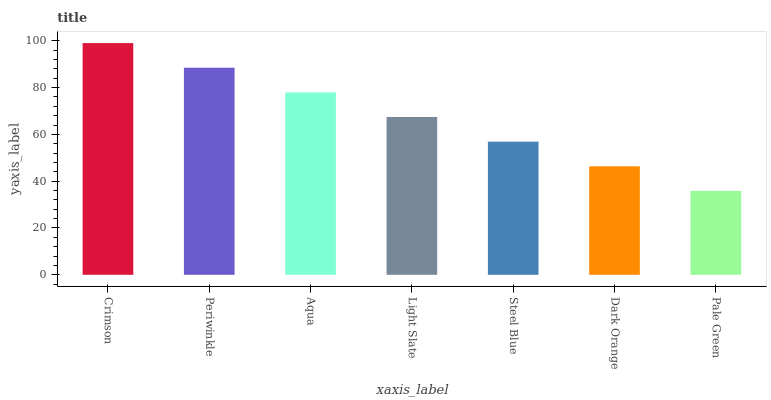Is Periwinkle the minimum?
Answer yes or no. No. Is Periwinkle the maximum?
Answer yes or no. No. Is Crimson greater than Periwinkle?
Answer yes or no. Yes. Is Periwinkle less than Crimson?
Answer yes or no. Yes. Is Periwinkle greater than Crimson?
Answer yes or no. No. Is Crimson less than Periwinkle?
Answer yes or no. No. Is Light Slate the high median?
Answer yes or no. Yes. Is Light Slate the low median?
Answer yes or no. Yes. Is Pale Green the high median?
Answer yes or no. No. Is Aqua the low median?
Answer yes or no. No. 